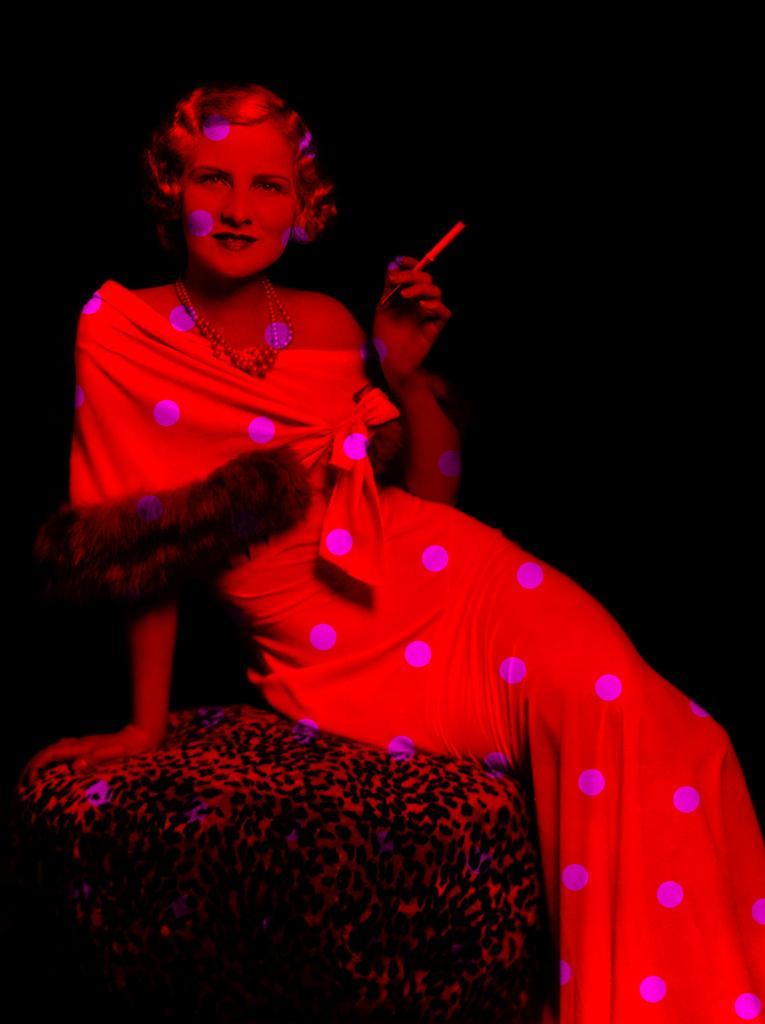Describe this image in one or two sentences. In this image we can see a woman sitting on the table holding a pen. 